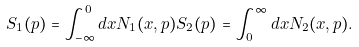Convert formula to latex. <formula><loc_0><loc_0><loc_500><loc_500>S _ { 1 } ( p ) = \int _ { - \infty } ^ { 0 } d x N _ { 1 } ( x , p ) S _ { 2 } ( p ) = \int _ { 0 } ^ { \infty } d x N _ { 2 } ( x , p ) .</formula> 